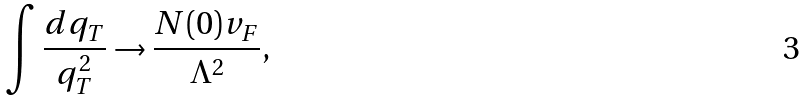Convert formula to latex. <formula><loc_0><loc_0><loc_500><loc_500>\int \frac { d q _ { T } } { q _ { T } ^ { 2 } } \rightarrow \frac { N ( 0 ) v _ { F } } { \Lambda ^ { 2 } } ,</formula> 